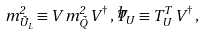Convert formula to latex. <formula><loc_0><loc_0><loc_500><loc_500>m ^ { 2 } _ { \tilde { U } _ { L } } \equiv V \, { m } _ { \tilde { Q } } ^ { 2 } \, V ^ { \dagger } \, , { \widehat { T } _ { U } } \equiv T _ { U } ^ { T } \, V ^ { \dagger } \, ,</formula> 